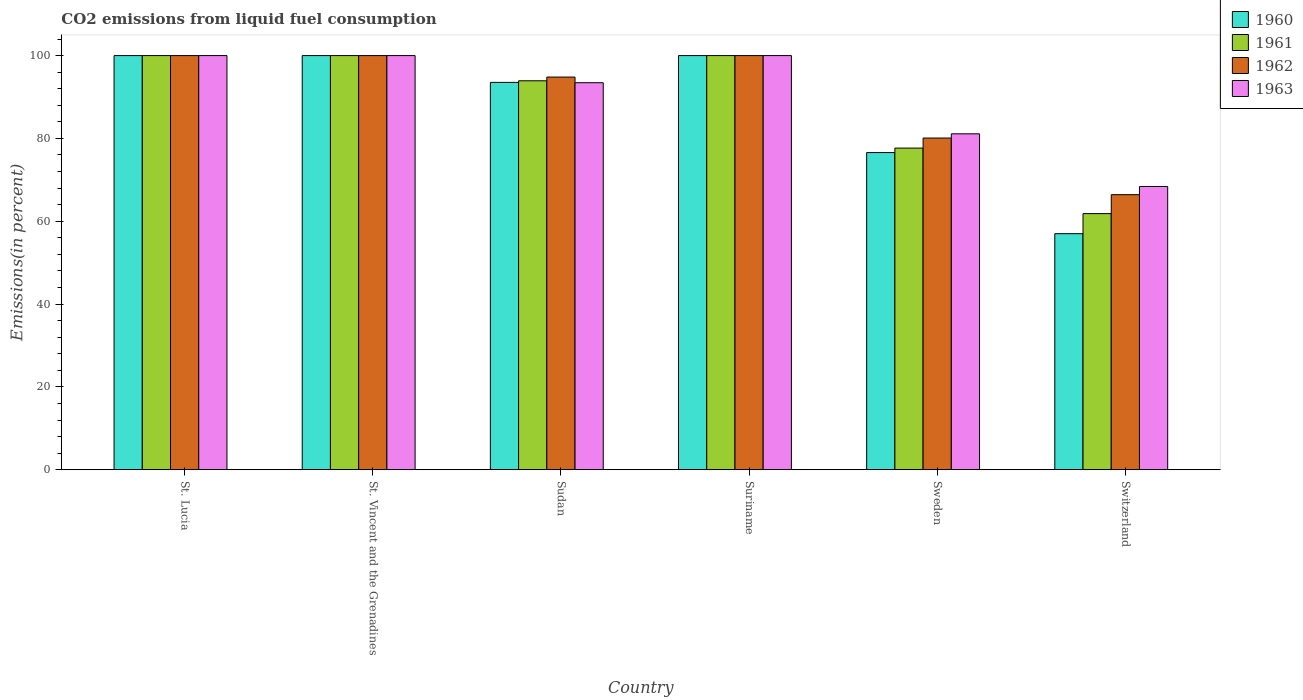How many different coloured bars are there?
Keep it short and to the point. 4. How many groups of bars are there?
Make the answer very short. 6. Are the number of bars per tick equal to the number of legend labels?
Offer a terse response. Yes. Are the number of bars on each tick of the X-axis equal?
Your answer should be very brief. Yes. How many bars are there on the 5th tick from the left?
Make the answer very short. 4. What is the label of the 5th group of bars from the left?
Give a very brief answer. Sweden. What is the total CO2 emitted in 1961 in Switzerland?
Your response must be concise. 61.85. Across all countries, what is the minimum total CO2 emitted in 1962?
Keep it short and to the point. 66.42. In which country was the total CO2 emitted in 1961 maximum?
Ensure brevity in your answer.  St. Lucia. In which country was the total CO2 emitted in 1963 minimum?
Provide a short and direct response. Switzerland. What is the total total CO2 emitted in 1963 in the graph?
Your response must be concise. 542.96. What is the difference between the total CO2 emitted in 1963 in St. Lucia and that in St. Vincent and the Grenadines?
Offer a terse response. 0. What is the difference between the total CO2 emitted in 1961 in St. Vincent and the Grenadines and the total CO2 emitted in 1963 in Suriname?
Your answer should be compact. 0. What is the average total CO2 emitted in 1961 per country?
Your answer should be compact. 88.91. What is the difference between the total CO2 emitted of/in 1961 and total CO2 emitted of/in 1963 in St. Vincent and the Grenadines?
Your response must be concise. 0. In how many countries, is the total CO2 emitted in 1960 greater than 12 %?
Your response must be concise. 6. What is the ratio of the total CO2 emitted in 1963 in Sudan to that in Sweden?
Your answer should be compact. 1.15. Is the difference between the total CO2 emitted in 1961 in St. Vincent and the Grenadines and Switzerland greater than the difference between the total CO2 emitted in 1963 in St. Vincent and the Grenadines and Switzerland?
Your answer should be compact. Yes. What is the difference between the highest and the lowest total CO2 emitted in 1963?
Your response must be concise. 31.6. In how many countries, is the total CO2 emitted in 1963 greater than the average total CO2 emitted in 1963 taken over all countries?
Provide a succinct answer. 4. Is it the case that in every country, the sum of the total CO2 emitted in 1961 and total CO2 emitted in 1963 is greater than the sum of total CO2 emitted in 1962 and total CO2 emitted in 1960?
Give a very brief answer. No. What does the 2nd bar from the left in Switzerland represents?
Offer a very short reply. 1961. What does the 2nd bar from the right in Sudan represents?
Your answer should be compact. 1962. Are all the bars in the graph horizontal?
Offer a very short reply. No. Where does the legend appear in the graph?
Offer a very short reply. Top right. How many legend labels are there?
Your answer should be very brief. 4. What is the title of the graph?
Provide a short and direct response. CO2 emissions from liquid fuel consumption. What is the label or title of the Y-axis?
Offer a terse response. Emissions(in percent). What is the Emissions(in percent) in 1961 in St. Lucia?
Provide a short and direct response. 100. What is the Emissions(in percent) in 1963 in St. Lucia?
Ensure brevity in your answer.  100. What is the Emissions(in percent) of 1960 in St. Vincent and the Grenadines?
Make the answer very short. 100. What is the Emissions(in percent) of 1960 in Sudan?
Your answer should be very brief. 93.53. What is the Emissions(in percent) in 1961 in Sudan?
Provide a short and direct response. 93.92. What is the Emissions(in percent) in 1962 in Sudan?
Ensure brevity in your answer.  94.81. What is the Emissions(in percent) in 1963 in Sudan?
Ensure brevity in your answer.  93.45. What is the Emissions(in percent) of 1960 in Suriname?
Provide a succinct answer. 100. What is the Emissions(in percent) of 1962 in Suriname?
Your response must be concise. 100. What is the Emissions(in percent) of 1960 in Sweden?
Your answer should be very brief. 76.58. What is the Emissions(in percent) in 1961 in Sweden?
Offer a very short reply. 77.67. What is the Emissions(in percent) of 1962 in Sweden?
Offer a very short reply. 80.1. What is the Emissions(in percent) of 1963 in Sweden?
Provide a short and direct response. 81.11. What is the Emissions(in percent) in 1960 in Switzerland?
Your answer should be very brief. 57.01. What is the Emissions(in percent) of 1961 in Switzerland?
Your response must be concise. 61.85. What is the Emissions(in percent) in 1962 in Switzerland?
Ensure brevity in your answer.  66.42. What is the Emissions(in percent) of 1963 in Switzerland?
Give a very brief answer. 68.4. Across all countries, what is the maximum Emissions(in percent) in 1960?
Offer a terse response. 100. Across all countries, what is the maximum Emissions(in percent) in 1961?
Your answer should be compact. 100. Across all countries, what is the maximum Emissions(in percent) of 1963?
Offer a very short reply. 100. Across all countries, what is the minimum Emissions(in percent) of 1960?
Offer a terse response. 57.01. Across all countries, what is the minimum Emissions(in percent) of 1961?
Give a very brief answer. 61.85. Across all countries, what is the minimum Emissions(in percent) of 1962?
Your answer should be very brief. 66.42. Across all countries, what is the minimum Emissions(in percent) in 1963?
Provide a succinct answer. 68.4. What is the total Emissions(in percent) of 1960 in the graph?
Your response must be concise. 527.12. What is the total Emissions(in percent) in 1961 in the graph?
Keep it short and to the point. 533.44. What is the total Emissions(in percent) of 1962 in the graph?
Your answer should be very brief. 541.33. What is the total Emissions(in percent) in 1963 in the graph?
Provide a short and direct response. 542.96. What is the difference between the Emissions(in percent) in 1960 in St. Lucia and that in St. Vincent and the Grenadines?
Your response must be concise. 0. What is the difference between the Emissions(in percent) of 1961 in St. Lucia and that in St. Vincent and the Grenadines?
Ensure brevity in your answer.  0. What is the difference between the Emissions(in percent) of 1963 in St. Lucia and that in St. Vincent and the Grenadines?
Provide a succinct answer. 0. What is the difference between the Emissions(in percent) of 1960 in St. Lucia and that in Sudan?
Provide a succinct answer. 6.47. What is the difference between the Emissions(in percent) in 1961 in St. Lucia and that in Sudan?
Provide a short and direct response. 6.08. What is the difference between the Emissions(in percent) in 1962 in St. Lucia and that in Sudan?
Give a very brief answer. 5.19. What is the difference between the Emissions(in percent) in 1963 in St. Lucia and that in Sudan?
Provide a short and direct response. 6.55. What is the difference between the Emissions(in percent) of 1960 in St. Lucia and that in Suriname?
Provide a short and direct response. 0. What is the difference between the Emissions(in percent) in 1961 in St. Lucia and that in Suriname?
Offer a very short reply. 0. What is the difference between the Emissions(in percent) of 1962 in St. Lucia and that in Suriname?
Ensure brevity in your answer.  0. What is the difference between the Emissions(in percent) in 1960 in St. Lucia and that in Sweden?
Your response must be concise. 23.41. What is the difference between the Emissions(in percent) in 1961 in St. Lucia and that in Sweden?
Give a very brief answer. 22.33. What is the difference between the Emissions(in percent) of 1962 in St. Lucia and that in Sweden?
Keep it short and to the point. 19.9. What is the difference between the Emissions(in percent) in 1963 in St. Lucia and that in Sweden?
Ensure brevity in your answer.  18.89. What is the difference between the Emissions(in percent) in 1960 in St. Lucia and that in Switzerland?
Your response must be concise. 42.99. What is the difference between the Emissions(in percent) in 1961 in St. Lucia and that in Switzerland?
Give a very brief answer. 38.15. What is the difference between the Emissions(in percent) of 1962 in St. Lucia and that in Switzerland?
Provide a short and direct response. 33.58. What is the difference between the Emissions(in percent) of 1963 in St. Lucia and that in Switzerland?
Your response must be concise. 31.6. What is the difference between the Emissions(in percent) in 1960 in St. Vincent and the Grenadines and that in Sudan?
Offer a very short reply. 6.47. What is the difference between the Emissions(in percent) in 1961 in St. Vincent and the Grenadines and that in Sudan?
Your answer should be compact. 6.08. What is the difference between the Emissions(in percent) in 1962 in St. Vincent and the Grenadines and that in Sudan?
Offer a very short reply. 5.19. What is the difference between the Emissions(in percent) of 1963 in St. Vincent and the Grenadines and that in Sudan?
Give a very brief answer. 6.55. What is the difference between the Emissions(in percent) in 1960 in St. Vincent and the Grenadines and that in Suriname?
Your answer should be very brief. 0. What is the difference between the Emissions(in percent) of 1961 in St. Vincent and the Grenadines and that in Suriname?
Your answer should be very brief. 0. What is the difference between the Emissions(in percent) in 1962 in St. Vincent and the Grenadines and that in Suriname?
Provide a succinct answer. 0. What is the difference between the Emissions(in percent) of 1963 in St. Vincent and the Grenadines and that in Suriname?
Provide a succinct answer. 0. What is the difference between the Emissions(in percent) of 1960 in St. Vincent and the Grenadines and that in Sweden?
Offer a very short reply. 23.41. What is the difference between the Emissions(in percent) in 1961 in St. Vincent and the Grenadines and that in Sweden?
Make the answer very short. 22.33. What is the difference between the Emissions(in percent) of 1962 in St. Vincent and the Grenadines and that in Sweden?
Provide a short and direct response. 19.9. What is the difference between the Emissions(in percent) of 1963 in St. Vincent and the Grenadines and that in Sweden?
Your response must be concise. 18.89. What is the difference between the Emissions(in percent) of 1960 in St. Vincent and the Grenadines and that in Switzerland?
Offer a very short reply. 42.99. What is the difference between the Emissions(in percent) of 1961 in St. Vincent and the Grenadines and that in Switzerland?
Your answer should be compact. 38.15. What is the difference between the Emissions(in percent) in 1962 in St. Vincent and the Grenadines and that in Switzerland?
Make the answer very short. 33.58. What is the difference between the Emissions(in percent) of 1963 in St. Vincent and the Grenadines and that in Switzerland?
Give a very brief answer. 31.6. What is the difference between the Emissions(in percent) of 1960 in Sudan and that in Suriname?
Offer a very short reply. -6.47. What is the difference between the Emissions(in percent) of 1961 in Sudan and that in Suriname?
Offer a terse response. -6.08. What is the difference between the Emissions(in percent) of 1962 in Sudan and that in Suriname?
Your answer should be compact. -5.19. What is the difference between the Emissions(in percent) of 1963 in Sudan and that in Suriname?
Your response must be concise. -6.55. What is the difference between the Emissions(in percent) of 1960 in Sudan and that in Sweden?
Give a very brief answer. 16.95. What is the difference between the Emissions(in percent) in 1961 in Sudan and that in Sweden?
Offer a terse response. 16.25. What is the difference between the Emissions(in percent) in 1962 in Sudan and that in Sweden?
Provide a succinct answer. 14.72. What is the difference between the Emissions(in percent) of 1963 in Sudan and that in Sweden?
Give a very brief answer. 12.34. What is the difference between the Emissions(in percent) of 1960 in Sudan and that in Switzerland?
Your answer should be compact. 36.52. What is the difference between the Emissions(in percent) of 1961 in Sudan and that in Switzerland?
Provide a short and direct response. 32.06. What is the difference between the Emissions(in percent) of 1962 in Sudan and that in Switzerland?
Offer a very short reply. 28.4. What is the difference between the Emissions(in percent) in 1963 in Sudan and that in Switzerland?
Give a very brief answer. 25.05. What is the difference between the Emissions(in percent) of 1960 in Suriname and that in Sweden?
Provide a succinct answer. 23.41. What is the difference between the Emissions(in percent) of 1961 in Suriname and that in Sweden?
Keep it short and to the point. 22.33. What is the difference between the Emissions(in percent) of 1962 in Suriname and that in Sweden?
Provide a succinct answer. 19.9. What is the difference between the Emissions(in percent) in 1963 in Suriname and that in Sweden?
Give a very brief answer. 18.89. What is the difference between the Emissions(in percent) of 1960 in Suriname and that in Switzerland?
Make the answer very short. 42.99. What is the difference between the Emissions(in percent) in 1961 in Suriname and that in Switzerland?
Ensure brevity in your answer.  38.15. What is the difference between the Emissions(in percent) of 1962 in Suriname and that in Switzerland?
Make the answer very short. 33.58. What is the difference between the Emissions(in percent) in 1963 in Suriname and that in Switzerland?
Provide a short and direct response. 31.6. What is the difference between the Emissions(in percent) in 1960 in Sweden and that in Switzerland?
Your response must be concise. 19.58. What is the difference between the Emissions(in percent) of 1961 in Sweden and that in Switzerland?
Ensure brevity in your answer.  15.82. What is the difference between the Emissions(in percent) of 1962 in Sweden and that in Switzerland?
Make the answer very short. 13.68. What is the difference between the Emissions(in percent) in 1963 in Sweden and that in Switzerland?
Offer a very short reply. 12.71. What is the difference between the Emissions(in percent) in 1960 in St. Lucia and the Emissions(in percent) in 1963 in St. Vincent and the Grenadines?
Provide a short and direct response. 0. What is the difference between the Emissions(in percent) in 1961 in St. Lucia and the Emissions(in percent) in 1962 in St. Vincent and the Grenadines?
Your answer should be very brief. 0. What is the difference between the Emissions(in percent) in 1960 in St. Lucia and the Emissions(in percent) in 1961 in Sudan?
Ensure brevity in your answer.  6.08. What is the difference between the Emissions(in percent) in 1960 in St. Lucia and the Emissions(in percent) in 1962 in Sudan?
Give a very brief answer. 5.19. What is the difference between the Emissions(in percent) of 1960 in St. Lucia and the Emissions(in percent) of 1963 in Sudan?
Keep it short and to the point. 6.55. What is the difference between the Emissions(in percent) in 1961 in St. Lucia and the Emissions(in percent) in 1962 in Sudan?
Make the answer very short. 5.19. What is the difference between the Emissions(in percent) of 1961 in St. Lucia and the Emissions(in percent) of 1963 in Sudan?
Offer a very short reply. 6.55. What is the difference between the Emissions(in percent) in 1962 in St. Lucia and the Emissions(in percent) in 1963 in Sudan?
Keep it short and to the point. 6.55. What is the difference between the Emissions(in percent) of 1960 in St. Lucia and the Emissions(in percent) of 1961 in Suriname?
Offer a very short reply. 0. What is the difference between the Emissions(in percent) in 1960 in St. Lucia and the Emissions(in percent) in 1962 in Suriname?
Offer a very short reply. 0. What is the difference between the Emissions(in percent) of 1960 in St. Lucia and the Emissions(in percent) of 1963 in Suriname?
Keep it short and to the point. 0. What is the difference between the Emissions(in percent) of 1961 in St. Lucia and the Emissions(in percent) of 1962 in Suriname?
Make the answer very short. 0. What is the difference between the Emissions(in percent) in 1962 in St. Lucia and the Emissions(in percent) in 1963 in Suriname?
Provide a short and direct response. 0. What is the difference between the Emissions(in percent) in 1960 in St. Lucia and the Emissions(in percent) in 1961 in Sweden?
Make the answer very short. 22.33. What is the difference between the Emissions(in percent) in 1960 in St. Lucia and the Emissions(in percent) in 1962 in Sweden?
Make the answer very short. 19.9. What is the difference between the Emissions(in percent) of 1960 in St. Lucia and the Emissions(in percent) of 1963 in Sweden?
Your answer should be very brief. 18.89. What is the difference between the Emissions(in percent) of 1961 in St. Lucia and the Emissions(in percent) of 1962 in Sweden?
Give a very brief answer. 19.9. What is the difference between the Emissions(in percent) in 1961 in St. Lucia and the Emissions(in percent) in 1963 in Sweden?
Your response must be concise. 18.89. What is the difference between the Emissions(in percent) in 1962 in St. Lucia and the Emissions(in percent) in 1963 in Sweden?
Your answer should be very brief. 18.89. What is the difference between the Emissions(in percent) of 1960 in St. Lucia and the Emissions(in percent) of 1961 in Switzerland?
Provide a short and direct response. 38.15. What is the difference between the Emissions(in percent) of 1960 in St. Lucia and the Emissions(in percent) of 1962 in Switzerland?
Provide a succinct answer. 33.58. What is the difference between the Emissions(in percent) in 1960 in St. Lucia and the Emissions(in percent) in 1963 in Switzerland?
Your response must be concise. 31.6. What is the difference between the Emissions(in percent) of 1961 in St. Lucia and the Emissions(in percent) of 1962 in Switzerland?
Ensure brevity in your answer.  33.58. What is the difference between the Emissions(in percent) in 1961 in St. Lucia and the Emissions(in percent) in 1963 in Switzerland?
Make the answer very short. 31.6. What is the difference between the Emissions(in percent) in 1962 in St. Lucia and the Emissions(in percent) in 1963 in Switzerland?
Give a very brief answer. 31.6. What is the difference between the Emissions(in percent) of 1960 in St. Vincent and the Grenadines and the Emissions(in percent) of 1961 in Sudan?
Provide a short and direct response. 6.08. What is the difference between the Emissions(in percent) in 1960 in St. Vincent and the Grenadines and the Emissions(in percent) in 1962 in Sudan?
Provide a succinct answer. 5.19. What is the difference between the Emissions(in percent) in 1960 in St. Vincent and the Grenadines and the Emissions(in percent) in 1963 in Sudan?
Provide a short and direct response. 6.55. What is the difference between the Emissions(in percent) of 1961 in St. Vincent and the Grenadines and the Emissions(in percent) of 1962 in Sudan?
Provide a succinct answer. 5.19. What is the difference between the Emissions(in percent) in 1961 in St. Vincent and the Grenadines and the Emissions(in percent) in 1963 in Sudan?
Provide a short and direct response. 6.55. What is the difference between the Emissions(in percent) in 1962 in St. Vincent and the Grenadines and the Emissions(in percent) in 1963 in Sudan?
Offer a very short reply. 6.55. What is the difference between the Emissions(in percent) in 1960 in St. Vincent and the Grenadines and the Emissions(in percent) in 1961 in Suriname?
Provide a short and direct response. 0. What is the difference between the Emissions(in percent) in 1960 in St. Vincent and the Grenadines and the Emissions(in percent) in 1962 in Suriname?
Your response must be concise. 0. What is the difference between the Emissions(in percent) in 1960 in St. Vincent and the Grenadines and the Emissions(in percent) in 1963 in Suriname?
Make the answer very short. 0. What is the difference between the Emissions(in percent) in 1960 in St. Vincent and the Grenadines and the Emissions(in percent) in 1961 in Sweden?
Ensure brevity in your answer.  22.33. What is the difference between the Emissions(in percent) in 1960 in St. Vincent and the Grenadines and the Emissions(in percent) in 1962 in Sweden?
Give a very brief answer. 19.9. What is the difference between the Emissions(in percent) of 1960 in St. Vincent and the Grenadines and the Emissions(in percent) of 1963 in Sweden?
Give a very brief answer. 18.89. What is the difference between the Emissions(in percent) in 1961 in St. Vincent and the Grenadines and the Emissions(in percent) in 1962 in Sweden?
Your answer should be very brief. 19.9. What is the difference between the Emissions(in percent) in 1961 in St. Vincent and the Grenadines and the Emissions(in percent) in 1963 in Sweden?
Give a very brief answer. 18.89. What is the difference between the Emissions(in percent) of 1962 in St. Vincent and the Grenadines and the Emissions(in percent) of 1963 in Sweden?
Your answer should be compact. 18.89. What is the difference between the Emissions(in percent) of 1960 in St. Vincent and the Grenadines and the Emissions(in percent) of 1961 in Switzerland?
Your answer should be compact. 38.15. What is the difference between the Emissions(in percent) of 1960 in St. Vincent and the Grenadines and the Emissions(in percent) of 1962 in Switzerland?
Give a very brief answer. 33.58. What is the difference between the Emissions(in percent) in 1960 in St. Vincent and the Grenadines and the Emissions(in percent) in 1963 in Switzerland?
Your response must be concise. 31.6. What is the difference between the Emissions(in percent) in 1961 in St. Vincent and the Grenadines and the Emissions(in percent) in 1962 in Switzerland?
Keep it short and to the point. 33.58. What is the difference between the Emissions(in percent) of 1961 in St. Vincent and the Grenadines and the Emissions(in percent) of 1963 in Switzerland?
Offer a terse response. 31.6. What is the difference between the Emissions(in percent) of 1962 in St. Vincent and the Grenadines and the Emissions(in percent) of 1963 in Switzerland?
Your answer should be very brief. 31.6. What is the difference between the Emissions(in percent) of 1960 in Sudan and the Emissions(in percent) of 1961 in Suriname?
Provide a short and direct response. -6.47. What is the difference between the Emissions(in percent) of 1960 in Sudan and the Emissions(in percent) of 1962 in Suriname?
Provide a short and direct response. -6.47. What is the difference between the Emissions(in percent) of 1960 in Sudan and the Emissions(in percent) of 1963 in Suriname?
Offer a terse response. -6.47. What is the difference between the Emissions(in percent) in 1961 in Sudan and the Emissions(in percent) in 1962 in Suriname?
Your response must be concise. -6.08. What is the difference between the Emissions(in percent) of 1961 in Sudan and the Emissions(in percent) of 1963 in Suriname?
Your response must be concise. -6.08. What is the difference between the Emissions(in percent) of 1962 in Sudan and the Emissions(in percent) of 1963 in Suriname?
Give a very brief answer. -5.19. What is the difference between the Emissions(in percent) of 1960 in Sudan and the Emissions(in percent) of 1961 in Sweden?
Offer a very short reply. 15.86. What is the difference between the Emissions(in percent) in 1960 in Sudan and the Emissions(in percent) in 1962 in Sweden?
Ensure brevity in your answer.  13.44. What is the difference between the Emissions(in percent) of 1960 in Sudan and the Emissions(in percent) of 1963 in Sweden?
Offer a very short reply. 12.42. What is the difference between the Emissions(in percent) in 1961 in Sudan and the Emissions(in percent) in 1962 in Sweden?
Offer a very short reply. 13.82. What is the difference between the Emissions(in percent) of 1961 in Sudan and the Emissions(in percent) of 1963 in Sweden?
Offer a terse response. 12.8. What is the difference between the Emissions(in percent) in 1962 in Sudan and the Emissions(in percent) in 1963 in Sweden?
Your answer should be compact. 13.7. What is the difference between the Emissions(in percent) of 1960 in Sudan and the Emissions(in percent) of 1961 in Switzerland?
Your answer should be very brief. 31.68. What is the difference between the Emissions(in percent) of 1960 in Sudan and the Emissions(in percent) of 1962 in Switzerland?
Keep it short and to the point. 27.11. What is the difference between the Emissions(in percent) in 1960 in Sudan and the Emissions(in percent) in 1963 in Switzerland?
Your answer should be very brief. 25.13. What is the difference between the Emissions(in percent) in 1961 in Sudan and the Emissions(in percent) in 1962 in Switzerland?
Ensure brevity in your answer.  27.5. What is the difference between the Emissions(in percent) in 1961 in Sudan and the Emissions(in percent) in 1963 in Switzerland?
Provide a succinct answer. 25.51. What is the difference between the Emissions(in percent) of 1962 in Sudan and the Emissions(in percent) of 1963 in Switzerland?
Your response must be concise. 26.41. What is the difference between the Emissions(in percent) in 1960 in Suriname and the Emissions(in percent) in 1961 in Sweden?
Your answer should be very brief. 22.33. What is the difference between the Emissions(in percent) of 1960 in Suriname and the Emissions(in percent) of 1962 in Sweden?
Make the answer very short. 19.9. What is the difference between the Emissions(in percent) in 1960 in Suriname and the Emissions(in percent) in 1963 in Sweden?
Ensure brevity in your answer.  18.89. What is the difference between the Emissions(in percent) of 1961 in Suriname and the Emissions(in percent) of 1962 in Sweden?
Keep it short and to the point. 19.9. What is the difference between the Emissions(in percent) in 1961 in Suriname and the Emissions(in percent) in 1963 in Sweden?
Offer a terse response. 18.89. What is the difference between the Emissions(in percent) in 1962 in Suriname and the Emissions(in percent) in 1963 in Sweden?
Give a very brief answer. 18.89. What is the difference between the Emissions(in percent) in 1960 in Suriname and the Emissions(in percent) in 1961 in Switzerland?
Your response must be concise. 38.15. What is the difference between the Emissions(in percent) in 1960 in Suriname and the Emissions(in percent) in 1962 in Switzerland?
Offer a very short reply. 33.58. What is the difference between the Emissions(in percent) in 1960 in Suriname and the Emissions(in percent) in 1963 in Switzerland?
Your response must be concise. 31.6. What is the difference between the Emissions(in percent) of 1961 in Suriname and the Emissions(in percent) of 1962 in Switzerland?
Give a very brief answer. 33.58. What is the difference between the Emissions(in percent) in 1961 in Suriname and the Emissions(in percent) in 1963 in Switzerland?
Give a very brief answer. 31.6. What is the difference between the Emissions(in percent) in 1962 in Suriname and the Emissions(in percent) in 1963 in Switzerland?
Give a very brief answer. 31.6. What is the difference between the Emissions(in percent) in 1960 in Sweden and the Emissions(in percent) in 1961 in Switzerland?
Offer a very short reply. 14.73. What is the difference between the Emissions(in percent) of 1960 in Sweden and the Emissions(in percent) of 1962 in Switzerland?
Give a very brief answer. 10.17. What is the difference between the Emissions(in percent) in 1960 in Sweden and the Emissions(in percent) in 1963 in Switzerland?
Keep it short and to the point. 8.18. What is the difference between the Emissions(in percent) in 1961 in Sweden and the Emissions(in percent) in 1962 in Switzerland?
Make the answer very short. 11.25. What is the difference between the Emissions(in percent) of 1961 in Sweden and the Emissions(in percent) of 1963 in Switzerland?
Offer a terse response. 9.27. What is the difference between the Emissions(in percent) in 1962 in Sweden and the Emissions(in percent) in 1963 in Switzerland?
Offer a very short reply. 11.69. What is the average Emissions(in percent) in 1960 per country?
Provide a short and direct response. 87.85. What is the average Emissions(in percent) of 1961 per country?
Provide a succinct answer. 88.91. What is the average Emissions(in percent) in 1962 per country?
Keep it short and to the point. 90.22. What is the average Emissions(in percent) in 1963 per country?
Ensure brevity in your answer.  90.49. What is the difference between the Emissions(in percent) in 1960 and Emissions(in percent) in 1961 in St. Lucia?
Your answer should be very brief. 0. What is the difference between the Emissions(in percent) in 1960 and Emissions(in percent) in 1962 in St. Lucia?
Offer a terse response. 0. What is the difference between the Emissions(in percent) of 1961 and Emissions(in percent) of 1962 in St. Lucia?
Your response must be concise. 0. What is the difference between the Emissions(in percent) in 1961 and Emissions(in percent) in 1963 in St. Lucia?
Ensure brevity in your answer.  0. What is the difference between the Emissions(in percent) in 1962 and Emissions(in percent) in 1963 in St. Lucia?
Provide a succinct answer. 0. What is the difference between the Emissions(in percent) of 1960 and Emissions(in percent) of 1961 in St. Vincent and the Grenadines?
Offer a very short reply. 0. What is the difference between the Emissions(in percent) in 1960 and Emissions(in percent) in 1962 in St. Vincent and the Grenadines?
Your answer should be very brief. 0. What is the difference between the Emissions(in percent) of 1960 and Emissions(in percent) of 1963 in St. Vincent and the Grenadines?
Ensure brevity in your answer.  0. What is the difference between the Emissions(in percent) in 1961 and Emissions(in percent) in 1963 in St. Vincent and the Grenadines?
Provide a short and direct response. 0. What is the difference between the Emissions(in percent) of 1962 and Emissions(in percent) of 1963 in St. Vincent and the Grenadines?
Ensure brevity in your answer.  0. What is the difference between the Emissions(in percent) in 1960 and Emissions(in percent) in 1961 in Sudan?
Your answer should be very brief. -0.38. What is the difference between the Emissions(in percent) in 1960 and Emissions(in percent) in 1962 in Sudan?
Provide a succinct answer. -1.28. What is the difference between the Emissions(in percent) in 1960 and Emissions(in percent) in 1963 in Sudan?
Provide a succinct answer. 0.08. What is the difference between the Emissions(in percent) in 1961 and Emissions(in percent) in 1962 in Sudan?
Provide a short and direct response. -0.9. What is the difference between the Emissions(in percent) of 1961 and Emissions(in percent) of 1963 in Sudan?
Make the answer very short. 0.47. What is the difference between the Emissions(in percent) of 1962 and Emissions(in percent) of 1963 in Sudan?
Your answer should be compact. 1.36. What is the difference between the Emissions(in percent) of 1960 and Emissions(in percent) of 1961 in Suriname?
Offer a very short reply. 0. What is the difference between the Emissions(in percent) of 1960 and Emissions(in percent) of 1963 in Suriname?
Your answer should be very brief. 0. What is the difference between the Emissions(in percent) in 1961 and Emissions(in percent) in 1962 in Suriname?
Make the answer very short. 0. What is the difference between the Emissions(in percent) in 1962 and Emissions(in percent) in 1963 in Suriname?
Provide a succinct answer. 0. What is the difference between the Emissions(in percent) in 1960 and Emissions(in percent) in 1961 in Sweden?
Make the answer very short. -1.08. What is the difference between the Emissions(in percent) of 1960 and Emissions(in percent) of 1962 in Sweden?
Your answer should be compact. -3.51. What is the difference between the Emissions(in percent) in 1960 and Emissions(in percent) in 1963 in Sweden?
Provide a succinct answer. -4.53. What is the difference between the Emissions(in percent) of 1961 and Emissions(in percent) of 1962 in Sweden?
Offer a terse response. -2.43. What is the difference between the Emissions(in percent) in 1961 and Emissions(in percent) in 1963 in Sweden?
Ensure brevity in your answer.  -3.44. What is the difference between the Emissions(in percent) of 1962 and Emissions(in percent) of 1963 in Sweden?
Offer a terse response. -1.02. What is the difference between the Emissions(in percent) of 1960 and Emissions(in percent) of 1961 in Switzerland?
Your answer should be compact. -4.85. What is the difference between the Emissions(in percent) in 1960 and Emissions(in percent) in 1962 in Switzerland?
Provide a short and direct response. -9.41. What is the difference between the Emissions(in percent) in 1960 and Emissions(in percent) in 1963 in Switzerland?
Offer a terse response. -11.4. What is the difference between the Emissions(in percent) in 1961 and Emissions(in percent) in 1962 in Switzerland?
Keep it short and to the point. -4.57. What is the difference between the Emissions(in percent) in 1961 and Emissions(in percent) in 1963 in Switzerland?
Make the answer very short. -6.55. What is the difference between the Emissions(in percent) in 1962 and Emissions(in percent) in 1963 in Switzerland?
Provide a short and direct response. -1.98. What is the ratio of the Emissions(in percent) of 1960 in St. Lucia to that in St. Vincent and the Grenadines?
Your answer should be very brief. 1. What is the ratio of the Emissions(in percent) of 1960 in St. Lucia to that in Sudan?
Provide a succinct answer. 1.07. What is the ratio of the Emissions(in percent) of 1961 in St. Lucia to that in Sudan?
Offer a very short reply. 1.06. What is the ratio of the Emissions(in percent) of 1962 in St. Lucia to that in Sudan?
Offer a very short reply. 1.05. What is the ratio of the Emissions(in percent) in 1963 in St. Lucia to that in Sudan?
Offer a terse response. 1.07. What is the ratio of the Emissions(in percent) of 1961 in St. Lucia to that in Suriname?
Your response must be concise. 1. What is the ratio of the Emissions(in percent) in 1962 in St. Lucia to that in Suriname?
Ensure brevity in your answer.  1. What is the ratio of the Emissions(in percent) in 1963 in St. Lucia to that in Suriname?
Make the answer very short. 1. What is the ratio of the Emissions(in percent) in 1960 in St. Lucia to that in Sweden?
Offer a very short reply. 1.31. What is the ratio of the Emissions(in percent) in 1961 in St. Lucia to that in Sweden?
Make the answer very short. 1.29. What is the ratio of the Emissions(in percent) in 1962 in St. Lucia to that in Sweden?
Keep it short and to the point. 1.25. What is the ratio of the Emissions(in percent) of 1963 in St. Lucia to that in Sweden?
Provide a succinct answer. 1.23. What is the ratio of the Emissions(in percent) in 1960 in St. Lucia to that in Switzerland?
Provide a succinct answer. 1.75. What is the ratio of the Emissions(in percent) of 1961 in St. Lucia to that in Switzerland?
Offer a terse response. 1.62. What is the ratio of the Emissions(in percent) in 1962 in St. Lucia to that in Switzerland?
Your answer should be compact. 1.51. What is the ratio of the Emissions(in percent) in 1963 in St. Lucia to that in Switzerland?
Offer a very short reply. 1.46. What is the ratio of the Emissions(in percent) in 1960 in St. Vincent and the Grenadines to that in Sudan?
Give a very brief answer. 1.07. What is the ratio of the Emissions(in percent) in 1961 in St. Vincent and the Grenadines to that in Sudan?
Offer a terse response. 1.06. What is the ratio of the Emissions(in percent) of 1962 in St. Vincent and the Grenadines to that in Sudan?
Your answer should be compact. 1.05. What is the ratio of the Emissions(in percent) in 1963 in St. Vincent and the Grenadines to that in Sudan?
Offer a terse response. 1.07. What is the ratio of the Emissions(in percent) of 1960 in St. Vincent and the Grenadines to that in Suriname?
Offer a terse response. 1. What is the ratio of the Emissions(in percent) in 1962 in St. Vincent and the Grenadines to that in Suriname?
Offer a very short reply. 1. What is the ratio of the Emissions(in percent) in 1963 in St. Vincent and the Grenadines to that in Suriname?
Offer a very short reply. 1. What is the ratio of the Emissions(in percent) in 1960 in St. Vincent and the Grenadines to that in Sweden?
Keep it short and to the point. 1.31. What is the ratio of the Emissions(in percent) of 1961 in St. Vincent and the Grenadines to that in Sweden?
Make the answer very short. 1.29. What is the ratio of the Emissions(in percent) of 1962 in St. Vincent and the Grenadines to that in Sweden?
Your answer should be very brief. 1.25. What is the ratio of the Emissions(in percent) of 1963 in St. Vincent and the Grenadines to that in Sweden?
Make the answer very short. 1.23. What is the ratio of the Emissions(in percent) of 1960 in St. Vincent and the Grenadines to that in Switzerland?
Your response must be concise. 1.75. What is the ratio of the Emissions(in percent) in 1961 in St. Vincent and the Grenadines to that in Switzerland?
Make the answer very short. 1.62. What is the ratio of the Emissions(in percent) of 1962 in St. Vincent and the Grenadines to that in Switzerland?
Keep it short and to the point. 1.51. What is the ratio of the Emissions(in percent) in 1963 in St. Vincent and the Grenadines to that in Switzerland?
Give a very brief answer. 1.46. What is the ratio of the Emissions(in percent) of 1960 in Sudan to that in Suriname?
Provide a short and direct response. 0.94. What is the ratio of the Emissions(in percent) of 1961 in Sudan to that in Suriname?
Your response must be concise. 0.94. What is the ratio of the Emissions(in percent) of 1962 in Sudan to that in Suriname?
Your answer should be compact. 0.95. What is the ratio of the Emissions(in percent) of 1963 in Sudan to that in Suriname?
Provide a succinct answer. 0.93. What is the ratio of the Emissions(in percent) in 1960 in Sudan to that in Sweden?
Your response must be concise. 1.22. What is the ratio of the Emissions(in percent) of 1961 in Sudan to that in Sweden?
Make the answer very short. 1.21. What is the ratio of the Emissions(in percent) in 1962 in Sudan to that in Sweden?
Your answer should be very brief. 1.18. What is the ratio of the Emissions(in percent) of 1963 in Sudan to that in Sweden?
Your answer should be compact. 1.15. What is the ratio of the Emissions(in percent) in 1960 in Sudan to that in Switzerland?
Make the answer very short. 1.64. What is the ratio of the Emissions(in percent) of 1961 in Sudan to that in Switzerland?
Your response must be concise. 1.52. What is the ratio of the Emissions(in percent) of 1962 in Sudan to that in Switzerland?
Your response must be concise. 1.43. What is the ratio of the Emissions(in percent) in 1963 in Sudan to that in Switzerland?
Provide a succinct answer. 1.37. What is the ratio of the Emissions(in percent) in 1960 in Suriname to that in Sweden?
Keep it short and to the point. 1.31. What is the ratio of the Emissions(in percent) in 1961 in Suriname to that in Sweden?
Give a very brief answer. 1.29. What is the ratio of the Emissions(in percent) of 1962 in Suriname to that in Sweden?
Keep it short and to the point. 1.25. What is the ratio of the Emissions(in percent) of 1963 in Suriname to that in Sweden?
Ensure brevity in your answer.  1.23. What is the ratio of the Emissions(in percent) in 1960 in Suriname to that in Switzerland?
Your answer should be very brief. 1.75. What is the ratio of the Emissions(in percent) of 1961 in Suriname to that in Switzerland?
Offer a very short reply. 1.62. What is the ratio of the Emissions(in percent) of 1962 in Suriname to that in Switzerland?
Provide a succinct answer. 1.51. What is the ratio of the Emissions(in percent) of 1963 in Suriname to that in Switzerland?
Give a very brief answer. 1.46. What is the ratio of the Emissions(in percent) in 1960 in Sweden to that in Switzerland?
Ensure brevity in your answer.  1.34. What is the ratio of the Emissions(in percent) of 1961 in Sweden to that in Switzerland?
Your answer should be very brief. 1.26. What is the ratio of the Emissions(in percent) in 1962 in Sweden to that in Switzerland?
Give a very brief answer. 1.21. What is the ratio of the Emissions(in percent) of 1963 in Sweden to that in Switzerland?
Provide a succinct answer. 1.19. What is the difference between the highest and the second highest Emissions(in percent) in 1960?
Your answer should be compact. 0. What is the difference between the highest and the second highest Emissions(in percent) in 1963?
Your answer should be very brief. 0. What is the difference between the highest and the lowest Emissions(in percent) in 1960?
Provide a succinct answer. 42.99. What is the difference between the highest and the lowest Emissions(in percent) of 1961?
Make the answer very short. 38.15. What is the difference between the highest and the lowest Emissions(in percent) of 1962?
Give a very brief answer. 33.58. What is the difference between the highest and the lowest Emissions(in percent) in 1963?
Make the answer very short. 31.6. 